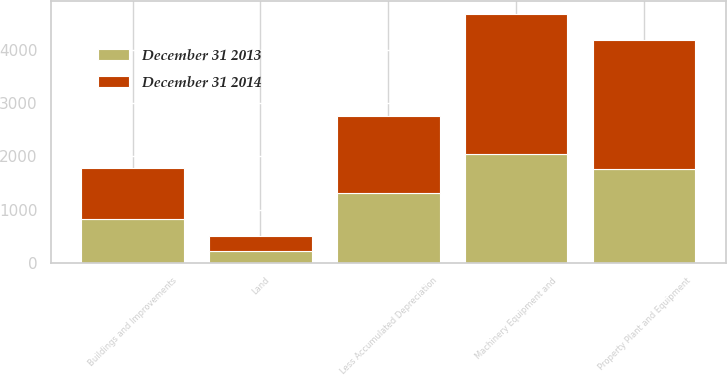<chart> <loc_0><loc_0><loc_500><loc_500><stacked_bar_chart><ecel><fcel>Land<fcel>Buildings and Improvements<fcel>Machinery Equipment and<fcel>Property Plant and Equipment<fcel>Less Accumulated Depreciation<nl><fcel>December 31 2014<fcel>281.8<fcel>955.1<fcel>2632<fcel>2426.5<fcel>1442.4<nl><fcel>December 31 2013<fcel>212.2<fcel>821<fcel>2047.9<fcel>1767.4<fcel>1313.7<nl></chart> 